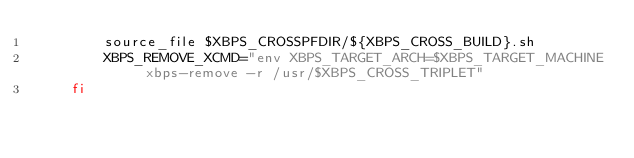<code> <loc_0><loc_0><loc_500><loc_500><_Bash_>        source_file $XBPS_CROSSPFDIR/${XBPS_CROSS_BUILD}.sh
        XBPS_REMOVE_XCMD="env XBPS_TARGET_ARCH=$XBPS_TARGET_MACHINE xbps-remove -r /usr/$XBPS_CROSS_TRIPLET"
    fi
</code> 